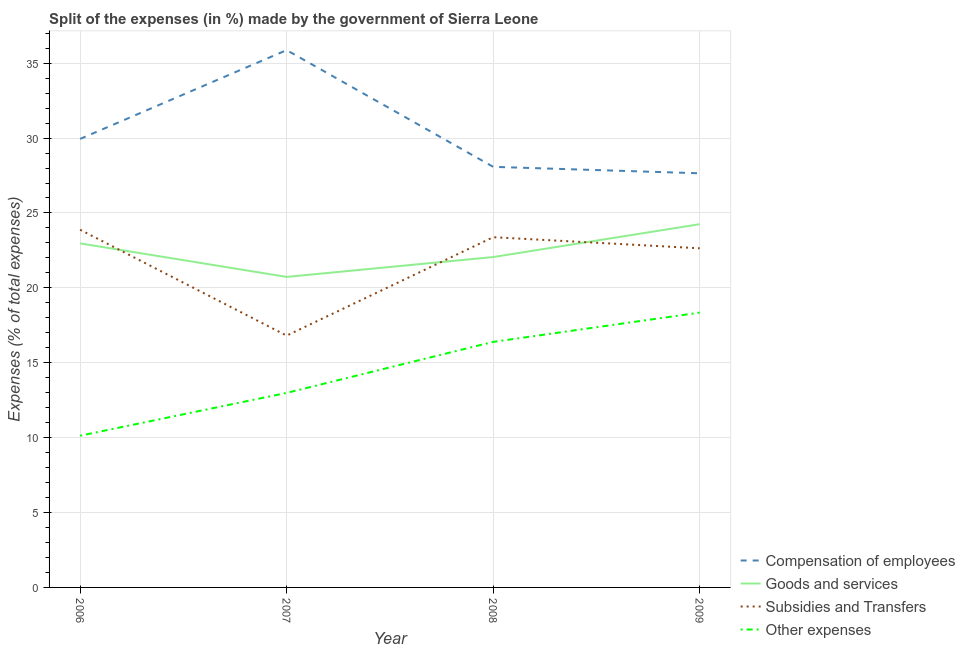Does the line corresponding to percentage of amount spent on compensation of employees intersect with the line corresponding to percentage of amount spent on subsidies?
Provide a short and direct response. No. What is the percentage of amount spent on goods and services in 2006?
Keep it short and to the point. 22.97. Across all years, what is the maximum percentage of amount spent on other expenses?
Offer a very short reply. 18.35. Across all years, what is the minimum percentage of amount spent on other expenses?
Keep it short and to the point. 10.13. In which year was the percentage of amount spent on goods and services maximum?
Your answer should be very brief. 2009. What is the total percentage of amount spent on other expenses in the graph?
Your answer should be very brief. 57.86. What is the difference between the percentage of amount spent on goods and services in 2006 and that in 2007?
Your response must be concise. 2.24. What is the difference between the percentage of amount spent on goods and services in 2007 and the percentage of amount spent on subsidies in 2006?
Keep it short and to the point. -3.15. What is the average percentage of amount spent on other expenses per year?
Your answer should be compact. 14.46. In the year 2008, what is the difference between the percentage of amount spent on compensation of employees and percentage of amount spent on other expenses?
Offer a very short reply. 11.69. In how many years, is the percentage of amount spent on goods and services greater than 21 %?
Offer a terse response. 3. What is the ratio of the percentage of amount spent on goods and services in 2008 to that in 2009?
Your answer should be compact. 0.91. What is the difference between the highest and the second highest percentage of amount spent on other expenses?
Ensure brevity in your answer.  1.96. What is the difference between the highest and the lowest percentage of amount spent on other expenses?
Ensure brevity in your answer.  8.22. Is the sum of the percentage of amount spent on compensation of employees in 2006 and 2007 greater than the maximum percentage of amount spent on other expenses across all years?
Provide a short and direct response. Yes. Is it the case that in every year, the sum of the percentage of amount spent on compensation of employees and percentage of amount spent on goods and services is greater than the sum of percentage of amount spent on other expenses and percentage of amount spent on subsidies?
Ensure brevity in your answer.  No. Is it the case that in every year, the sum of the percentage of amount spent on compensation of employees and percentage of amount spent on goods and services is greater than the percentage of amount spent on subsidies?
Offer a terse response. Yes. Does the percentage of amount spent on compensation of employees monotonically increase over the years?
Provide a short and direct response. No. How many lines are there?
Offer a very short reply. 4. How many years are there in the graph?
Provide a short and direct response. 4. What is the difference between two consecutive major ticks on the Y-axis?
Give a very brief answer. 5. Does the graph contain grids?
Your response must be concise. Yes. How many legend labels are there?
Your answer should be compact. 4. What is the title of the graph?
Provide a short and direct response. Split of the expenses (in %) made by the government of Sierra Leone. What is the label or title of the X-axis?
Keep it short and to the point. Year. What is the label or title of the Y-axis?
Keep it short and to the point. Expenses (% of total expenses). What is the Expenses (% of total expenses) of Compensation of employees in 2006?
Give a very brief answer. 29.94. What is the Expenses (% of total expenses) in Goods and services in 2006?
Make the answer very short. 22.97. What is the Expenses (% of total expenses) of Subsidies and Transfers in 2006?
Your response must be concise. 23.88. What is the Expenses (% of total expenses) in Other expenses in 2006?
Offer a terse response. 10.13. What is the Expenses (% of total expenses) in Compensation of employees in 2007?
Give a very brief answer. 35.87. What is the Expenses (% of total expenses) of Goods and services in 2007?
Ensure brevity in your answer.  20.73. What is the Expenses (% of total expenses) in Subsidies and Transfers in 2007?
Your answer should be compact. 16.81. What is the Expenses (% of total expenses) in Other expenses in 2007?
Ensure brevity in your answer.  12.99. What is the Expenses (% of total expenses) in Compensation of employees in 2008?
Provide a short and direct response. 28.08. What is the Expenses (% of total expenses) in Goods and services in 2008?
Your response must be concise. 22.06. What is the Expenses (% of total expenses) in Subsidies and Transfers in 2008?
Keep it short and to the point. 23.38. What is the Expenses (% of total expenses) of Other expenses in 2008?
Your response must be concise. 16.39. What is the Expenses (% of total expenses) of Compensation of employees in 2009?
Provide a short and direct response. 27.65. What is the Expenses (% of total expenses) in Goods and services in 2009?
Give a very brief answer. 24.25. What is the Expenses (% of total expenses) of Subsidies and Transfers in 2009?
Keep it short and to the point. 22.64. What is the Expenses (% of total expenses) in Other expenses in 2009?
Give a very brief answer. 18.35. Across all years, what is the maximum Expenses (% of total expenses) of Compensation of employees?
Provide a succinct answer. 35.87. Across all years, what is the maximum Expenses (% of total expenses) in Goods and services?
Keep it short and to the point. 24.25. Across all years, what is the maximum Expenses (% of total expenses) of Subsidies and Transfers?
Make the answer very short. 23.88. Across all years, what is the maximum Expenses (% of total expenses) of Other expenses?
Your answer should be very brief. 18.35. Across all years, what is the minimum Expenses (% of total expenses) of Compensation of employees?
Keep it short and to the point. 27.65. Across all years, what is the minimum Expenses (% of total expenses) of Goods and services?
Keep it short and to the point. 20.73. Across all years, what is the minimum Expenses (% of total expenses) in Subsidies and Transfers?
Offer a terse response. 16.81. Across all years, what is the minimum Expenses (% of total expenses) in Other expenses?
Provide a succinct answer. 10.13. What is the total Expenses (% of total expenses) in Compensation of employees in the graph?
Your answer should be very brief. 121.55. What is the total Expenses (% of total expenses) of Goods and services in the graph?
Ensure brevity in your answer.  90.01. What is the total Expenses (% of total expenses) in Subsidies and Transfers in the graph?
Offer a terse response. 86.72. What is the total Expenses (% of total expenses) of Other expenses in the graph?
Make the answer very short. 57.86. What is the difference between the Expenses (% of total expenses) of Compensation of employees in 2006 and that in 2007?
Your answer should be very brief. -5.93. What is the difference between the Expenses (% of total expenses) in Goods and services in 2006 and that in 2007?
Provide a succinct answer. 2.24. What is the difference between the Expenses (% of total expenses) in Subsidies and Transfers in 2006 and that in 2007?
Make the answer very short. 7.07. What is the difference between the Expenses (% of total expenses) of Other expenses in 2006 and that in 2007?
Your answer should be very brief. -2.86. What is the difference between the Expenses (% of total expenses) of Compensation of employees in 2006 and that in 2008?
Keep it short and to the point. 1.86. What is the difference between the Expenses (% of total expenses) of Goods and services in 2006 and that in 2008?
Your response must be concise. 0.91. What is the difference between the Expenses (% of total expenses) of Subsidies and Transfers in 2006 and that in 2008?
Offer a very short reply. 0.5. What is the difference between the Expenses (% of total expenses) in Other expenses in 2006 and that in 2008?
Offer a terse response. -6.26. What is the difference between the Expenses (% of total expenses) of Compensation of employees in 2006 and that in 2009?
Your answer should be very brief. 2.29. What is the difference between the Expenses (% of total expenses) of Goods and services in 2006 and that in 2009?
Offer a terse response. -1.28. What is the difference between the Expenses (% of total expenses) of Subsidies and Transfers in 2006 and that in 2009?
Offer a terse response. 1.24. What is the difference between the Expenses (% of total expenses) in Other expenses in 2006 and that in 2009?
Give a very brief answer. -8.22. What is the difference between the Expenses (% of total expenses) of Compensation of employees in 2007 and that in 2008?
Offer a very short reply. 7.79. What is the difference between the Expenses (% of total expenses) in Goods and services in 2007 and that in 2008?
Keep it short and to the point. -1.33. What is the difference between the Expenses (% of total expenses) in Subsidies and Transfers in 2007 and that in 2008?
Your answer should be compact. -6.57. What is the difference between the Expenses (% of total expenses) in Other expenses in 2007 and that in 2008?
Provide a succinct answer. -3.41. What is the difference between the Expenses (% of total expenses) of Compensation of employees in 2007 and that in 2009?
Offer a terse response. 8.22. What is the difference between the Expenses (% of total expenses) in Goods and services in 2007 and that in 2009?
Offer a terse response. -3.52. What is the difference between the Expenses (% of total expenses) of Subsidies and Transfers in 2007 and that in 2009?
Offer a very short reply. -5.83. What is the difference between the Expenses (% of total expenses) of Other expenses in 2007 and that in 2009?
Ensure brevity in your answer.  -5.36. What is the difference between the Expenses (% of total expenses) of Compensation of employees in 2008 and that in 2009?
Make the answer very short. 0.43. What is the difference between the Expenses (% of total expenses) in Goods and services in 2008 and that in 2009?
Give a very brief answer. -2.19. What is the difference between the Expenses (% of total expenses) of Subsidies and Transfers in 2008 and that in 2009?
Make the answer very short. 0.74. What is the difference between the Expenses (% of total expenses) of Other expenses in 2008 and that in 2009?
Your response must be concise. -1.96. What is the difference between the Expenses (% of total expenses) of Compensation of employees in 2006 and the Expenses (% of total expenses) of Goods and services in 2007?
Your response must be concise. 9.21. What is the difference between the Expenses (% of total expenses) in Compensation of employees in 2006 and the Expenses (% of total expenses) in Subsidies and Transfers in 2007?
Offer a terse response. 13.13. What is the difference between the Expenses (% of total expenses) of Compensation of employees in 2006 and the Expenses (% of total expenses) of Other expenses in 2007?
Offer a terse response. 16.96. What is the difference between the Expenses (% of total expenses) of Goods and services in 2006 and the Expenses (% of total expenses) of Subsidies and Transfers in 2007?
Offer a very short reply. 6.16. What is the difference between the Expenses (% of total expenses) in Goods and services in 2006 and the Expenses (% of total expenses) in Other expenses in 2007?
Your response must be concise. 9.98. What is the difference between the Expenses (% of total expenses) of Subsidies and Transfers in 2006 and the Expenses (% of total expenses) of Other expenses in 2007?
Offer a terse response. 10.89. What is the difference between the Expenses (% of total expenses) of Compensation of employees in 2006 and the Expenses (% of total expenses) of Goods and services in 2008?
Provide a short and direct response. 7.89. What is the difference between the Expenses (% of total expenses) of Compensation of employees in 2006 and the Expenses (% of total expenses) of Subsidies and Transfers in 2008?
Your response must be concise. 6.56. What is the difference between the Expenses (% of total expenses) in Compensation of employees in 2006 and the Expenses (% of total expenses) in Other expenses in 2008?
Provide a succinct answer. 13.55. What is the difference between the Expenses (% of total expenses) of Goods and services in 2006 and the Expenses (% of total expenses) of Subsidies and Transfers in 2008?
Offer a very short reply. -0.41. What is the difference between the Expenses (% of total expenses) in Goods and services in 2006 and the Expenses (% of total expenses) in Other expenses in 2008?
Provide a short and direct response. 6.58. What is the difference between the Expenses (% of total expenses) of Subsidies and Transfers in 2006 and the Expenses (% of total expenses) of Other expenses in 2008?
Offer a very short reply. 7.49. What is the difference between the Expenses (% of total expenses) in Compensation of employees in 2006 and the Expenses (% of total expenses) in Goods and services in 2009?
Offer a terse response. 5.69. What is the difference between the Expenses (% of total expenses) in Compensation of employees in 2006 and the Expenses (% of total expenses) in Subsidies and Transfers in 2009?
Provide a short and direct response. 7.3. What is the difference between the Expenses (% of total expenses) in Compensation of employees in 2006 and the Expenses (% of total expenses) in Other expenses in 2009?
Provide a succinct answer. 11.6. What is the difference between the Expenses (% of total expenses) of Goods and services in 2006 and the Expenses (% of total expenses) of Subsidies and Transfers in 2009?
Provide a short and direct response. 0.33. What is the difference between the Expenses (% of total expenses) of Goods and services in 2006 and the Expenses (% of total expenses) of Other expenses in 2009?
Keep it short and to the point. 4.62. What is the difference between the Expenses (% of total expenses) in Subsidies and Transfers in 2006 and the Expenses (% of total expenses) in Other expenses in 2009?
Provide a succinct answer. 5.53. What is the difference between the Expenses (% of total expenses) of Compensation of employees in 2007 and the Expenses (% of total expenses) of Goods and services in 2008?
Your answer should be very brief. 13.82. What is the difference between the Expenses (% of total expenses) of Compensation of employees in 2007 and the Expenses (% of total expenses) of Subsidies and Transfers in 2008?
Make the answer very short. 12.49. What is the difference between the Expenses (% of total expenses) in Compensation of employees in 2007 and the Expenses (% of total expenses) in Other expenses in 2008?
Provide a short and direct response. 19.48. What is the difference between the Expenses (% of total expenses) in Goods and services in 2007 and the Expenses (% of total expenses) in Subsidies and Transfers in 2008?
Your response must be concise. -2.65. What is the difference between the Expenses (% of total expenses) of Goods and services in 2007 and the Expenses (% of total expenses) of Other expenses in 2008?
Give a very brief answer. 4.34. What is the difference between the Expenses (% of total expenses) in Subsidies and Transfers in 2007 and the Expenses (% of total expenses) in Other expenses in 2008?
Provide a succinct answer. 0.42. What is the difference between the Expenses (% of total expenses) of Compensation of employees in 2007 and the Expenses (% of total expenses) of Goods and services in 2009?
Provide a succinct answer. 11.62. What is the difference between the Expenses (% of total expenses) of Compensation of employees in 2007 and the Expenses (% of total expenses) of Subsidies and Transfers in 2009?
Your response must be concise. 13.23. What is the difference between the Expenses (% of total expenses) in Compensation of employees in 2007 and the Expenses (% of total expenses) in Other expenses in 2009?
Make the answer very short. 17.53. What is the difference between the Expenses (% of total expenses) of Goods and services in 2007 and the Expenses (% of total expenses) of Subsidies and Transfers in 2009?
Your response must be concise. -1.91. What is the difference between the Expenses (% of total expenses) in Goods and services in 2007 and the Expenses (% of total expenses) in Other expenses in 2009?
Your response must be concise. 2.38. What is the difference between the Expenses (% of total expenses) of Subsidies and Transfers in 2007 and the Expenses (% of total expenses) of Other expenses in 2009?
Make the answer very short. -1.54. What is the difference between the Expenses (% of total expenses) in Compensation of employees in 2008 and the Expenses (% of total expenses) in Goods and services in 2009?
Provide a succinct answer. 3.83. What is the difference between the Expenses (% of total expenses) in Compensation of employees in 2008 and the Expenses (% of total expenses) in Subsidies and Transfers in 2009?
Your response must be concise. 5.44. What is the difference between the Expenses (% of total expenses) in Compensation of employees in 2008 and the Expenses (% of total expenses) in Other expenses in 2009?
Your answer should be compact. 9.73. What is the difference between the Expenses (% of total expenses) in Goods and services in 2008 and the Expenses (% of total expenses) in Subsidies and Transfers in 2009?
Give a very brief answer. -0.58. What is the difference between the Expenses (% of total expenses) in Goods and services in 2008 and the Expenses (% of total expenses) in Other expenses in 2009?
Your response must be concise. 3.71. What is the difference between the Expenses (% of total expenses) in Subsidies and Transfers in 2008 and the Expenses (% of total expenses) in Other expenses in 2009?
Provide a short and direct response. 5.03. What is the average Expenses (% of total expenses) in Compensation of employees per year?
Your answer should be very brief. 30.39. What is the average Expenses (% of total expenses) in Goods and services per year?
Make the answer very short. 22.5. What is the average Expenses (% of total expenses) of Subsidies and Transfers per year?
Offer a very short reply. 21.68. What is the average Expenses (% of total expenses) in Other expenses per year?
Offer a terse response. 14.46. In the year 2006, what is the difference between the Expenses (% of total expenses) in Compensation of employees and Expenses (% of total expenses) in Goods and services?
Provide a succinct answer. 6.97. In the year 2006, what is the difference between the Expenses (% of total expenses) of Compensation of employees and Expenses (% of total expenses) of Subsidies and Transfers?
Your response must be concise. 6.06. In the year 2006, what is the difference between the Expenses (% of total expenses) in Compensation of employees and Expenses (% of total expenses) in Other expenses?
Ensure brevity in your answer.  19.81. In the year 2006, what is the difference between the Expenses (% of total expenses) in Goods and services and Expenses (% of total expenses) in Subsidies and Transfers?
Ensure brevity in your answer.  -0.91. In the year 2006, what is the difference between the Expenses (% of total expenses) in Goods and services and Expenses (% of total expenses) in Other expenses?
Keep it short and to the point. 12.84. In the year 2006, what is the difference between the Expenses (% of total expenses) in Subsidies and Transfers and Expenses (% of total expenses) in Other expenses?
Give a very brief answer. 13.75. In the year 2007, what is the difference between the Expenses (% of total expenses) of Compensation of employees and Expenses (% of total expenses) of Goods and services?
Offer a very short reply. 15.14. In the year 2007, what is the difference between the Expenses (% of total expenses) of Compensation of employees and Expenses (% of total expenses) of Subsidies and Transfers?
Your answer should be compact. 19.06. In the year 2007, what is the difference between the Expenses (% of total expenses) of Compensation of employees and Expenses (% of total expenses) of Other expenses?
Ensure brevity in your answer.  22.89. In the year 2007, what is the difference between the Expenses (% of total expenses) of Goods and services and Expenses (% of total expenses) of Subsidies and Transfers?
Your answer should be compact. 3.92. In the year 2007, what is the difference between the Expenses (% of total expenses) of Goods and services and Expenses (% of total expenses) of Other expenses?
Your response must be concise. 7.74. In the year 2007, what is the difference between the Expenses (% of total expenses) in Subsidies and Transfers and Expenses (% of total expenses) in Other expenses?
Provide a succinct answer. 3.82. In the year 2008, what is the difference between the Expenses (% of total expenses) of Compensation of employees and Expenses (% of total expenses) of Goods and services?
Your answer should be compact. 6.02. In the year 2008, what is the difference between the Expenses (% of total expenses) in Compensation of employees and Expenses (% of total expenses) in Subsidies and Transfers?
Give a very brief answer. 4.7. In the year 2008, what is the difference between the Expenses (% of total expenses) in Compensation of employees and Expenses (% of total expenses) in Other expenses?
Make the answer very short. 11.69. In the year 2008, what is the difference between the Expenses (% of total expenses) in Goods and services and Expenses (% of total expenses) in Subsidies and Transfers?
Ensure brevity in your answer.  -1.32. In the year 2008, what is the difference between the Expenses (% of total expenses) of Goods and services and Expenses (% of total expenses) of Other expenses?
Offer a terse response. 5.66. In the year 2008, what is the difference between the Expenses (% of total expenses) in Subsidies and Transfers and Expenses (% of total expenses) in Other expenses?
Give a very brief answer. 6.99. In the year 2009, what is the difference between the Expenses (% of total expenses) in Compensation of employees and Expenses (% of total expenses) in Goods and services?
Offer a terse response. 3.4. In the year 2009, what is the difference between the Expenses (% of total expenses) of Compensation of employees and Expenses (% of total expenses) of Subsidies and Transfers?
Keep it short and to the point. 5.01. In the year 2009, what is the difference between the Expenses (% of total expenses) in Compensation of employees and Expenses (% of total expenses) in Other expenses?
Your answer should be very brief. 9.3. In the year 2009, what is the difference between the Expenses (% of total expenses) of Goods and services and Expenses (% of total expenses) of Subsidies and Transfers?
Your answer should be compact. 1.61. In the year 2009, what is the difference between the Expenses (% of total expenses) of Goods and services and Expenses (% of total expenses) of Other expenses?
Your response must be concise. 5.9. In the year 2009, what is the difference between the Expenses (% of total expenses) in Subsidies and Transfers and Expenses (% of total expenses) in Other expenses?
Offer a terse response. 4.29. What is the ratio of the Expenses (% of total expenses) of Compensation of employees in 2006 to that in 2007?
Your answer should be very brief. 0.83. What is the ratio of the Expenses (% of total expenses) in Goods and services in 2006 to that in 2007?
Provide a short and direct response. 1.11. What is the ratio of the Expenses (% of total expenses) of Subsidies and Transfers in 2006 to that in 2007?
Keep it short and to the point. 1.42. What is the ratio of the Expenses (% of total expenses) in Other expenses in 2006 to that in 2007?
Your answer should be compact. 0.78. What is the ratio of the Expenses (% of total expenses) in Compensation of employees in 2006 to that in 2008?
Your answer should be compact. 1.07. What is the ratio of the Expenses (% of total expenses) of Goods and services in 2006 to that in 2008?
Keep it short and to the point. 1.04. What is the ratio of the Expenses (% of total expenses) of Subsidies and Transfers in 2006 to that in 2008?
Your answer should be compact. 1.02. What is the ratio of the Expenses (% of total expenses) in Other expenses in 2006 to that in 2008?
Make the answer very short. 0.62. What is the ratio of the Expenses (% of total expenses) of Compensation of employees in 2006 to that in 2009?
Make the answer very short. 1.08. What is the ratio of the Expenses (% of total expenses) of Goods and services in 2006 to that in 2009?
Your answer should be compact. 0.95. What is the ratio of the Expenses (% of total expenses) in Subsidies and Transfers in 2006 to that in 2009?
Make the answer very short. 1.05. What is the ratio of the Expenses (% of total expenses) of Other expenses in 2006 to that in 2009?
Keep it short and to the point. 0.55. What is the ratio of the Expenses (% of total expenses) in Compensation of employees in 2007 to that in 2008?
Ensure brevity in your answer.  1.28. What is the ratio of the Expenses (% of total expenses) in Goods and services in 2007 to that in 2008?
Offer a terse response. 0.94. What is the ratio of the Expenses (% of total expenses) in Subsidies and Transfers in 2007 to that in 2008?
Provide a succinct answer. 0.72. What is the ratio of the Expenses (% of total expenses) of Other expenses in 2007 to that in 2008?
Keep it short and to the point. 0.79. What is the ratio of the Expenses (% of total expenses) of Compensation of employees in 2007 to that in 2009?
Ensure brevity in your answer.  1.3. What is the ratio of the Expenses (% of total expenses) in Goods and services in 2007 to that in 2009?
Your answer should be compact. 0.85. What is the ratio of the Expenses (% of total expenses) of Subsidies and Transfers in 2007 to that in 2009?
Provide a short and direct response. 0.74. What is the ratio of the Expenses (% of total expenses) of Other expenses in 2007 to that in 2009?
Make the answer very short. 0.71. What is the ratio of the Expenses (% of total expenses) of Compensation of employees in 2008 to that in 2009?
Keep it short and to the point. 1.02. What is the ratio of the Expenses (% of total expenses) in Goods and services in 2008 to that in 2009?
Offer a terse response. 0.91. What is the ratio of the Expenses (% of total expenses) in Subsidies and Transfers in 2008 to that in 2009?
Provide a short and direct response. 1.03. What is the ratio of the Expenses (% of total expenses) of Other expenses in 2008 to that in 2009?
Keep it short and to the point. 0.89. What is the difference between the highest and the second highest Expenses (% of total expenses) in Compensation of employees?
Offer a terse response. 5.93. What is the difference between the highest and the second highest Expenses (% of total expenses) in Goods and services?
Your answer should be very brief. 1.28. What is the difference between the highest and the second highest Expenses (% of total expenses) of Subsidies and Transfers?
Your response must be concise. 0.5. What is the difference between the highest and the second highest Expenses (% of total expenses) of Other expenses?
Your answer should be very brief. 1.96. What is the difference between the highest and the lowest Expenses (% of total expenses) of Compensation of employees?
Give a very brief answer. 8.22. What is the difference between the highest and the lowest Expenses (% of total expenses) in Goods and services?
Your answer should be very brief. 3.52. What is the difference between the highest and the lowest Expenses (% of total expenses) of Subsidies and Transfers?
Your response must be concise. 7.07. What is the difference between the highest and the lowest Expenses (% of total expenses) of Other expenses?
Your answer should be very brief. 8.22. 